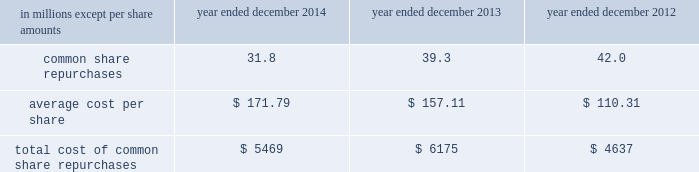Notes to consolidated financial statements guarantees of subsidiaries .
Group inc .
Fully and unconditionally guarantees the securities issued by gs finance corp. , a wholly-owned finance subsidiary of the group inc .
Has guaranteed the payment obligations of goldman , sachs & co .
( gs&co. ) , gs bank usa and goldman sachs execution & clearing , l.p .
( gsec ) , subject to certain exceptions .
In november 2008 , the firm contributed subsidiaries into gs bank usa , and group inc .
Agreed to guarantee the reimbursement of certain losses , including credit-related losses , relating to assets held by the contributed entities .
In connection with this guarantee , group inc .
Also agreed to pledge to gs bank usa certain collateral , including interests in subsidiaries and other illiquid assets .
In addition , group inc .
Guarantees many of the obligations of its other consolidated subsidiaries on a transaction-by- transaction basis , as negotiated with counterparties .
Group inc .
Is unable to develop an estimate of the maximum payout under its subsidiary guarantees ; however , because these guaranteed obligations are also obligations of consolidated subsidiaries , group inc . 2019s liabilities as guarantor are not separately disclosed .
Note 19 .
Shareholders 2019 equity common equity dividends declared per common share were $ 2.25 in 2014 , $ 2.05 in 2013 and $ 1.77 in 2012 .
On january 15 , 2015 , group inc .
Declared a dividend of $ 0.60 per common share to be paid on march 30 , 2015 to common shareholders of record on march 2 , 2015 .
The firm 2019s share repurchase program is intended to help maintain the appropriate level of common equity .
The share repurchase program is effected primarily through regular open-market purchases ( which may include repurchase plans designed to comply with rule 10b5-1 ) , the amounts and timing of which are determined primarily by the firm 2019s current and projected capital position , but which may also be influenced by general market conditions and the prevailing price and trading volumes of the firm 2019s common stock .
Prior to repurchasing common stock , the firm must receive confirmation that the federal reserve board does not object to such capital actions .
The table below presents the amount of common stock repurchased by the firm under the share repurchase program during 2014 , 2013 and 2012. .
Total cost of common share repurchases $ 5469 $ 6175 $ 4637 pursuant to the terms of certain share-based compensation plans , employees may remit shares to the firm or the firm may cancel restricted stock units ( rsus ) or stock options to satisfy minimum statutory employee tax withholding requirements and the exercise price of stock options .
Under these plans , during 2014 , 2013 and 2012 , employees remitted 174489 shares , 161211 shares and 33477 shares with a total value of $ 31 million , $ 25 million and $ 3 million , and the firm cancelled 5.8 million , 4.0 million and 12.7 million of rsus with a total value of $ 974 million , $ 599 million and $ 1.44 billion .
Under these plans , the firm also cancelled 15.6 million stock options with a total value of $ 2.65 billion during 2014 .
170 goldman sachs 2014 annual report .
What was the percentage change in the total cost of common share repurchases between 2012 and 2013? 
Computations: ((6175 - 4637) / 4637)
Answer: 0.33168. 